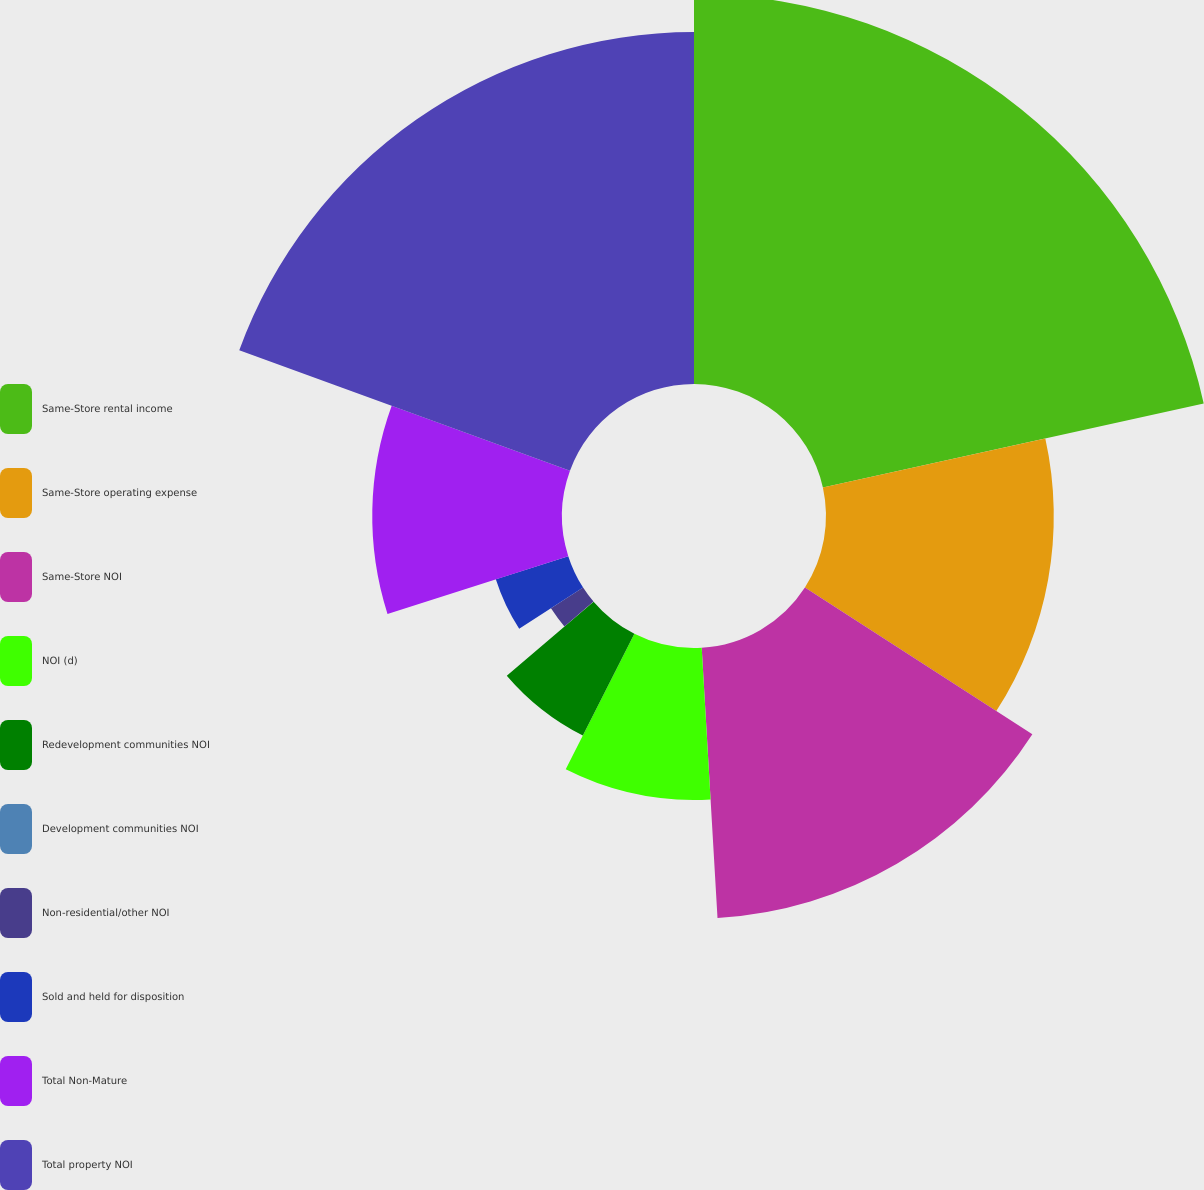<chart> <loc_0><loc_0><loc_500><loc_500><pie_chart><fcel>Same-Store rental income<fcel>Same-Store operating expense<fcel>Same-Store NOI<fcel>NOI (d)<fcel>Redevelopment communities NOI<fcel>Development communities NOI<fcel>Non-residential/other NOI<fcel>Sold and held for disposition<fcel>Total Non-Mature<fcel>Total property NOI<nl><fcel>21.54%<fcel>12.58%<fcel>14.95%<fcel>8.39%<fcel>6.3%<fcel>0.01%<fcel>2.11%<fcel>4.2%<fcel>10.48%<fcel>19.44%<nl></chart> 